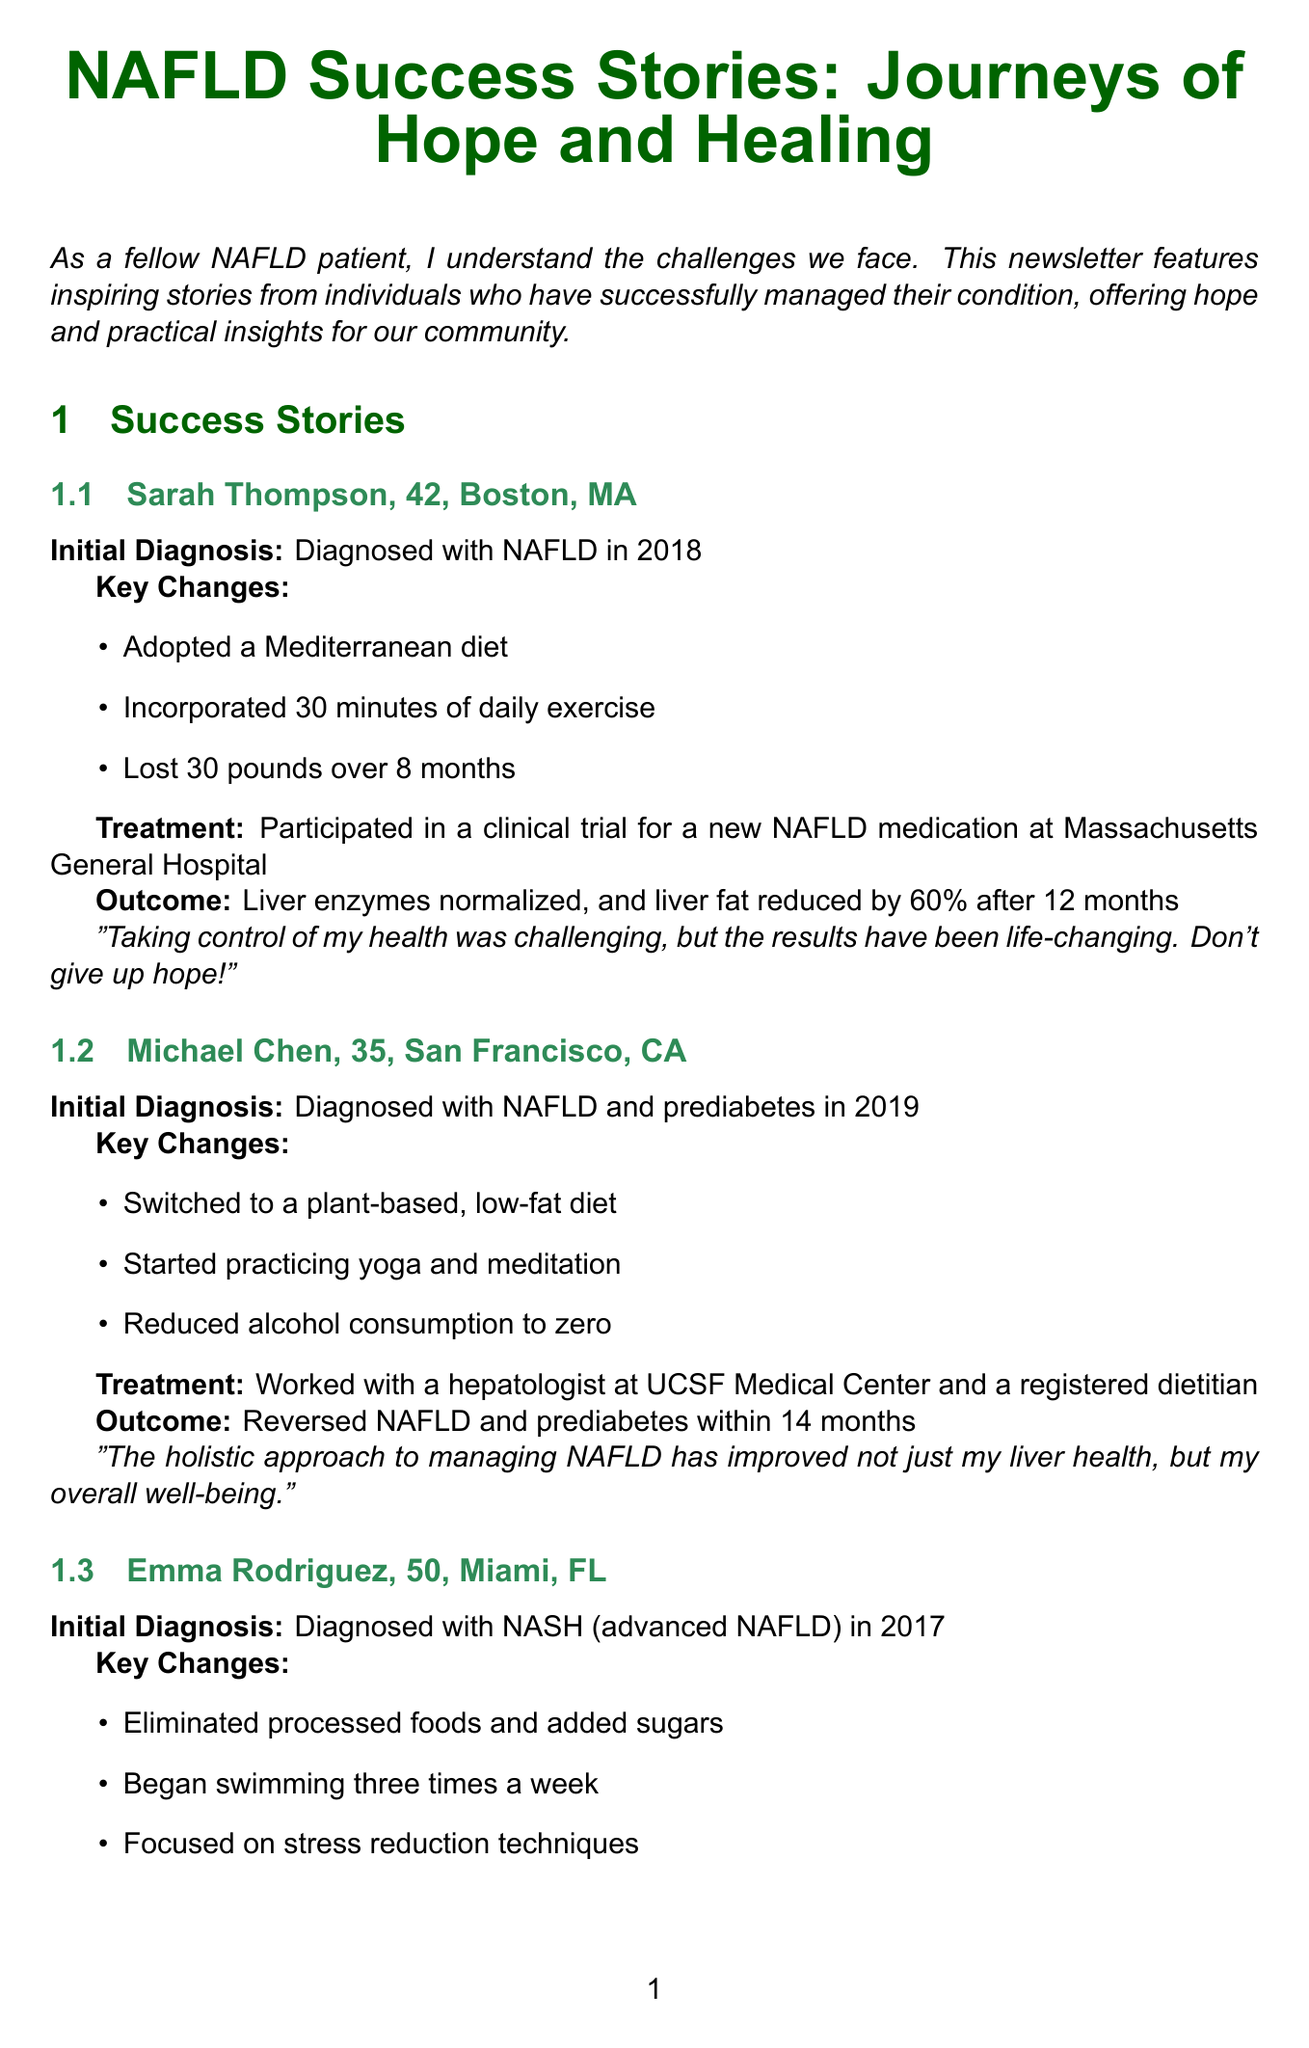What was Sarah Thompson's initial diagnosis year? Sarah Thompson was diagnosed with NAFLD in 2018, as stated in her story.
Answer: 2018 How much weight did Sarah Thompson lose? The document mentions that Sarah Thompson lost 30 pounds over 8 months as part of her lifestyle changes.
Answer: 30 pounds What diet did Michael Chen switch to? Michael Chen switched to a plant-based, low-fat diet, as highlighted in his success story.
Answer: Plant-based, low-fat diet What was Emma Rodriguez's initial diagnosis? Emma Rodriguez was diagnosed with NASH (advanced NAFLD) in 2017, as indicated in her section.
Answer: NASH (advanced NAFLD) What improvement did Emma Rodriguez achieve in liver fibrosis? Emma Rodriguez's liver fibrosis improved from stage 3 to stage 1 after 18 months, as mentioned in her outcome.
Answer: From stage 3 to stage 1 What is a key component of NAFLD treatment according to Dr. Amanda Nguyen? Dr. Amanda Nguyen states that lifestyle modifications remain the cornerstone of NAFLD treatment, emphasizing its importance.
Answer: Lifestyle modifications Which study suggests benefits for non-diabetic NAFLD patients? The newsletter refers to a study published in the Journal of Hepatology, 2023, discussing vitamin E supplementation.
Answer: Journal of Hepatology, 2023 How can one join the NAFLD Support Group? The document provides a link to the Facebook group where individuals can join the NAFLD Support Group, indicating it's a platform for community support.
Answer: Facebook What is Dr. Amanda Nguyen's title? The title of Dr. Amanda Nguyen, mentioned in the expert insights, is Hepatologist at Johns Hopkins Medicine.
Answer: Hepatologist at Johns Hopkins Medicine 